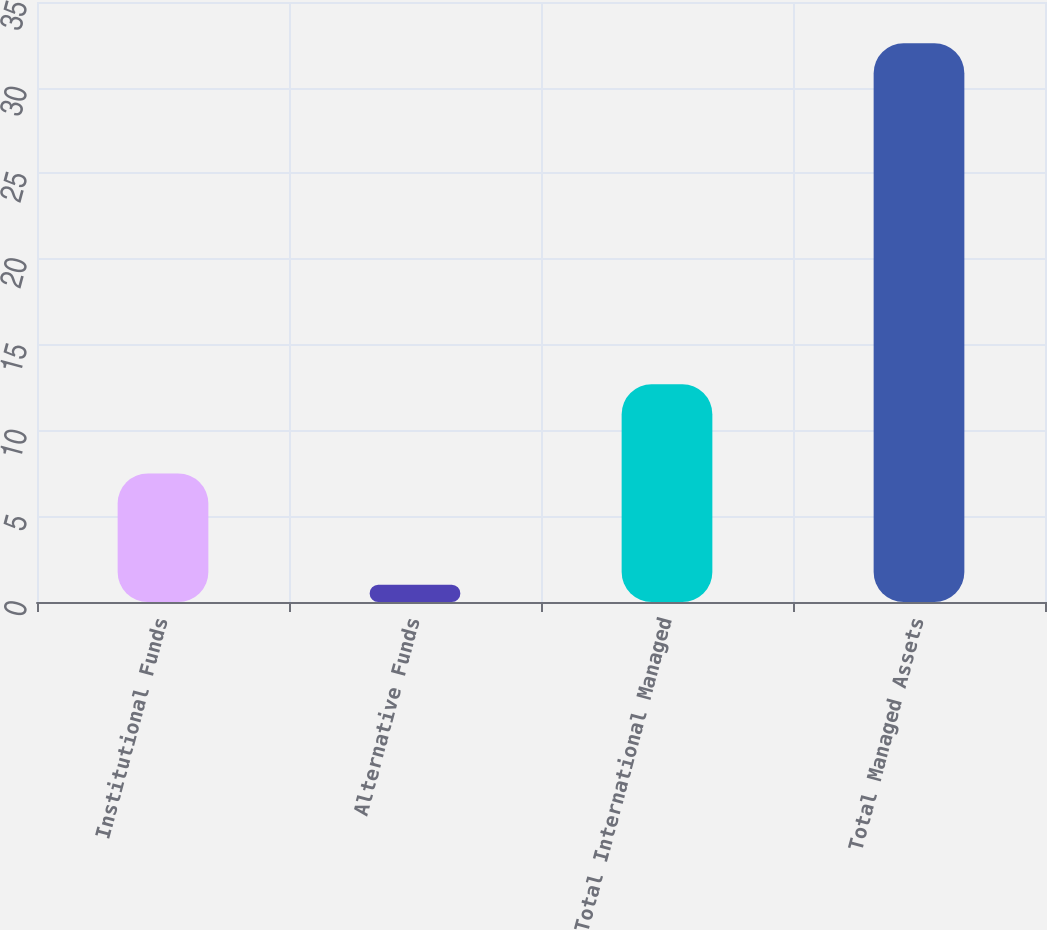Convert chart to OTSL. <chart><loc_0><loc_0><loc_500><loc_500><bar_chart><fcel>Institutional Funds<fcel>Alternative Funds<fcel>Total International Managed<fcel>Total Managed Assets<nl><fcel>7.5<fcel>1<fcel>12.7<fcel>32.6<nl></chart> 